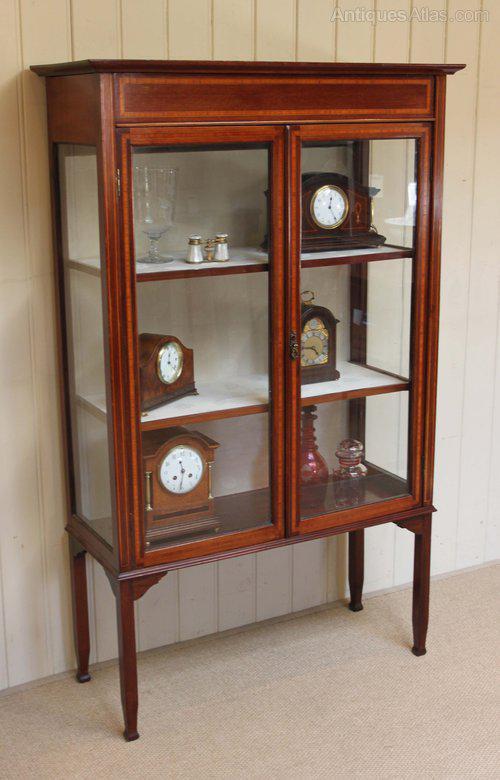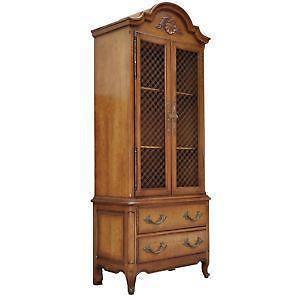The first image is the image on the left, the second image is the image on the right. Considering the images on both sides, is "A wood china cupboard in one image has a curved glass front and glass shelves, carving above the door and small feet." valid? Answer yes or no. No. 